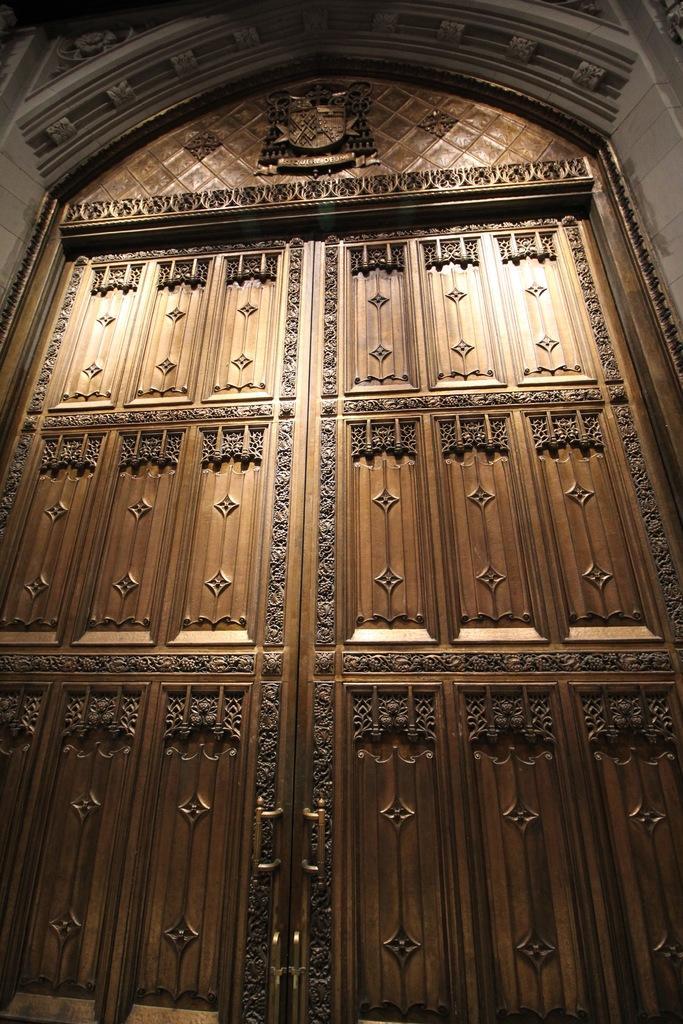Please provide a concise description of this image. In this image we can see a door made of different design. 